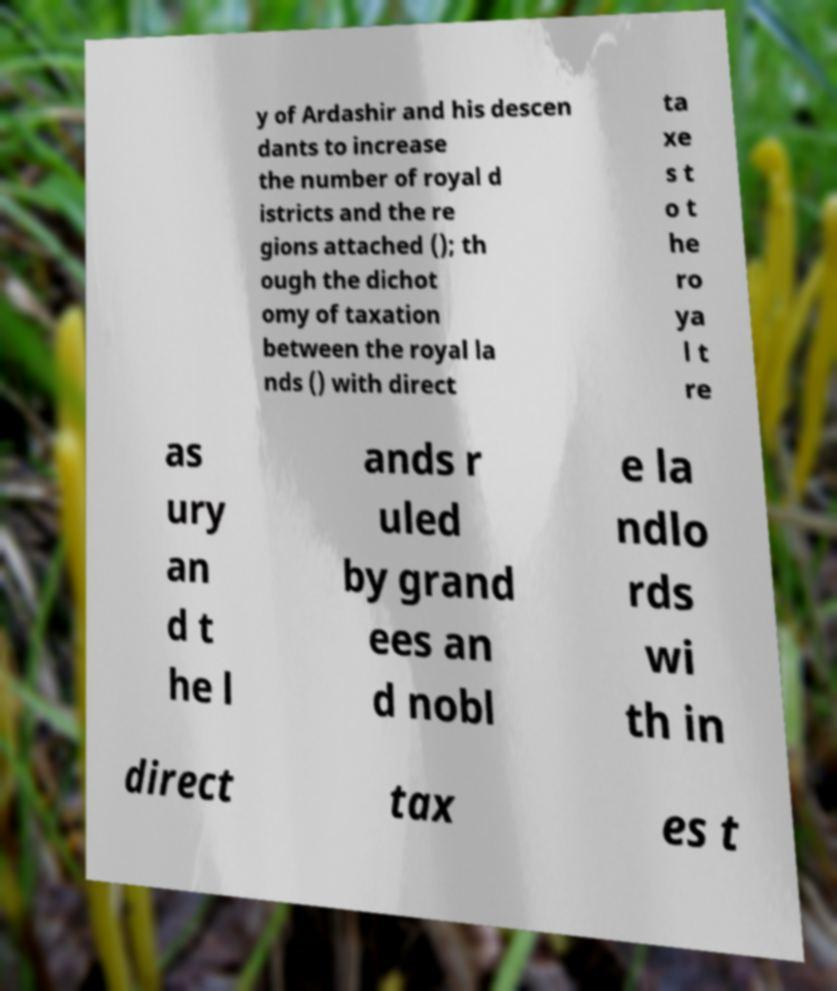I need the written content from this picture converted into text. Can you do that? y of Ardashir and his descen dants to increase the number of royal d istricts and the re gions attached (); th ough the dichot omy of taxation between the royal la nds () with direct ta xe s t o t he ro ya l t re as ury an d t he l ands r uled by grand ees an d nobl e la ndlo rds wi th in direct tax es t 